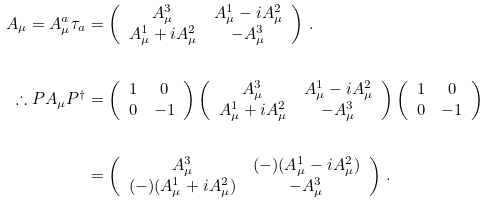Convert formula to latex. <formula><loc_0><loc_0><loc_500><loc_500>A _ { \mu } = A _ { \mu } ^ { a } \tau _ { a } & = \left ( \begin{array} { c c } A _ { \mu } ^ { 3 } & A ^ { 1 } _ { \mu } - i A ^ { 2 } _ { \mu } \\ A ^ { 1 } _ { \mu } + i A _ { \mu } ^ { 2 } & - A ^ { 3 } _ { \mu } \end{array} \right ) \, . \\ \\ \therefore P A _ { \mu } P ^ { \dagger } & = \left ( \begin{array} { c c } 1 & 0 \\ 0 & - 1 \end{array} \right ) \left ( \begin{array} { c c } A _ { \mu } ^ { 3 } & A ^ { 1 } _ { \mu } - i A ^ { 2 } _ { \mu } \\ A ^ { 1 } _ { \mu } + i A _ { \mu } ^ { 2 } & - A ^ { 3 } _ { \mu } \end{array} \right ) \left ( \begin{array} { c c } 1 & 0 \\ 0 & - 1 \end{array} \right ) \\ \\ & = \left ( \begin{array} { c c } A _ { \mu } ^ { 3 } & ( - ) ( A ^ { 1 } _ { \mu } - i A ^ { 2 } _ { \mu } ) \\ ( - ) ( A ^ { 1 } _ { \mu } + i A _ { \mu } ^ { 2 } ) & - A ^ { 3 } _ { \mu } \end{array} \right ) \, .</formula> 